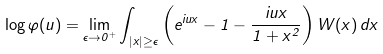<formula> <loc_0><loc_0><loc_500><loc_500>\log \varphi ( u ) = \lim _ { \epsilon \to 0 ^ { + } } \int _ { | x | \geq \epsilon } \left ( e ^ { i u x } - 1 - \frac { i u x } { 1 + x ^ { 2 } } \right ) W ( x ) \, d x</formula> 